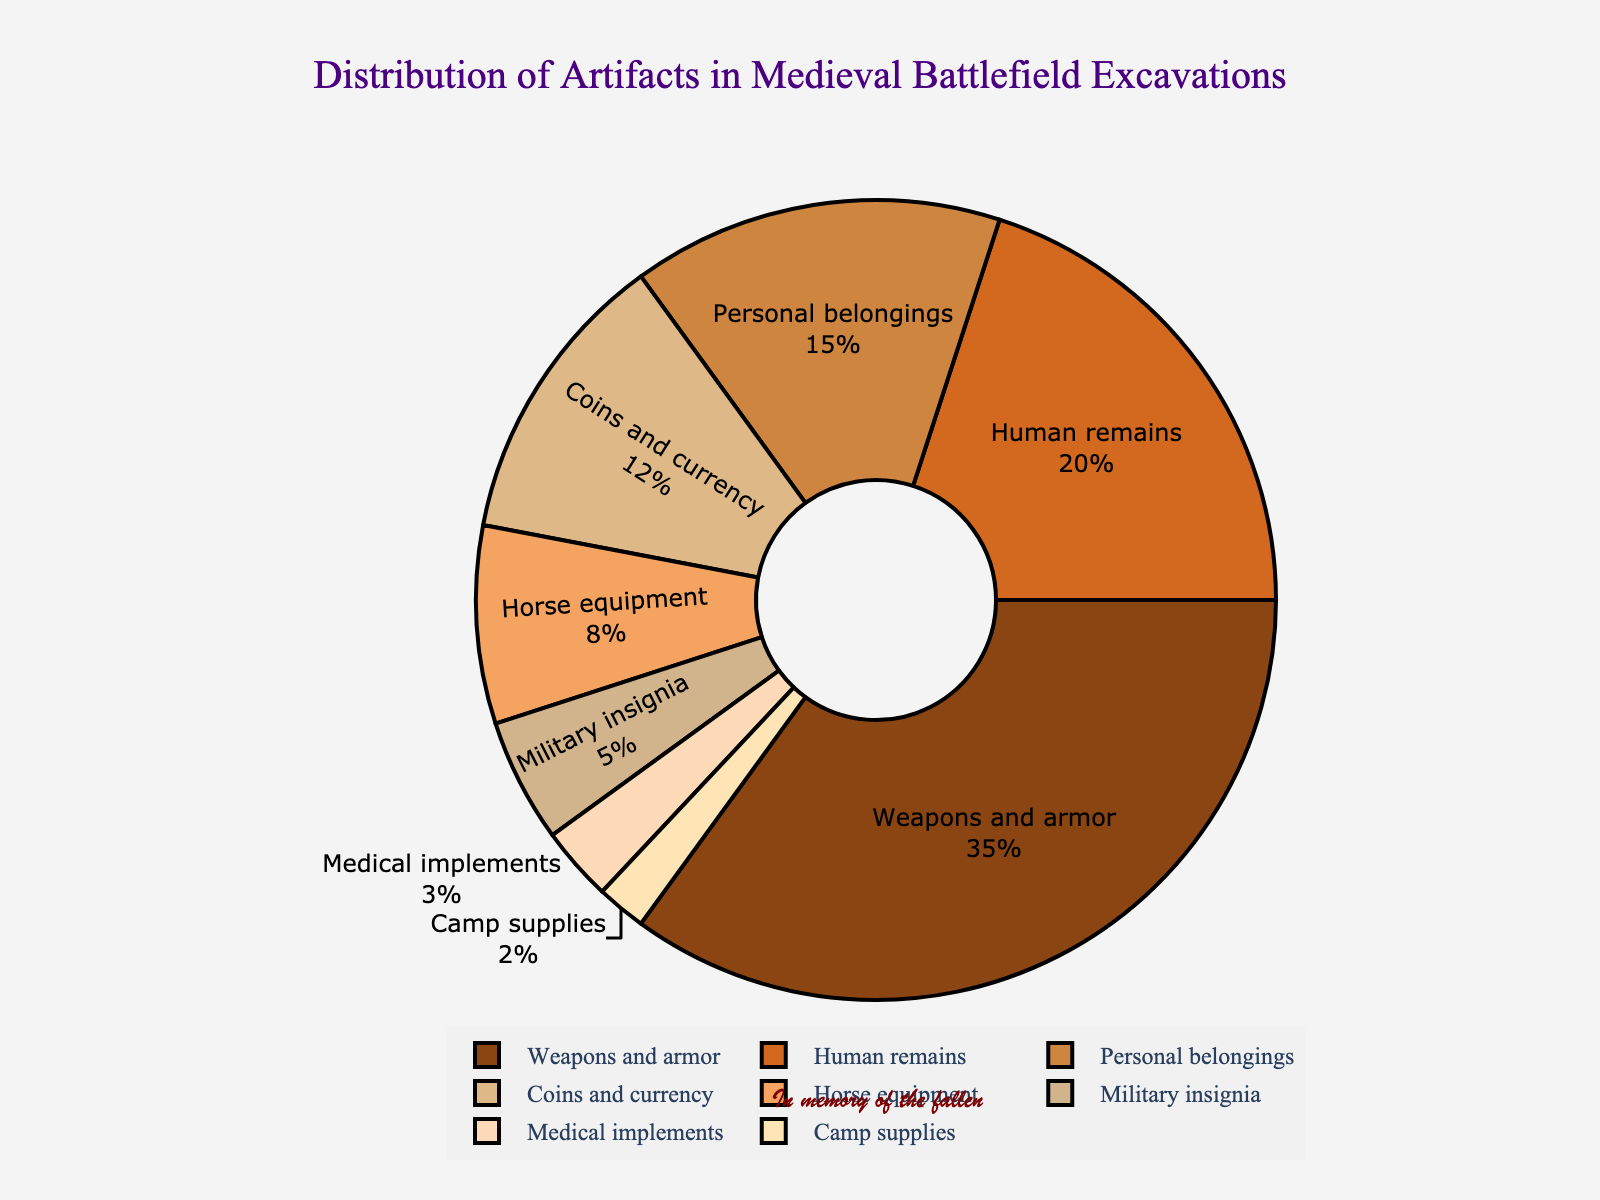What's the category with the largest percentage? The category with the largest percentage is the one with the highest value in the pie chart. In this case, it's "Weapons and armor" with 35%.
Answer: Weapons and armor Which category has a greater percentage: Human remains or Personal belongings? To determine this, we compare the percentages of the two categories. Human remains have 20%, while Personal belongings have 15%. Therefore, Human remains have a greater percentage.
Answer: Human remains What is the combined percentage of Coins and currency, Horse equipment, and Military insignia? To find the combined percentage, we need to sum the percentages of the three categories: Coins and currency (12%) + Horse equipment (8%) + Military insignia (5%) = 25%.
Answer: 25% Is the percentage of Medical implements greater than or equal to Camp supplies? We compare the values of both categories. Medical implements have 3%, and Camp supplies have 2%. Since 3% is greater than 2%, the percentage of Medical implements is greater than Camp supplies.
Answer: Yes What is the difference in percentage between Weapons and armor and Human remains? To find the difference, subtract the percentage of Human remains from the percentage of Weapons and armor: 35% - 20% = 15%.
Answer: 15% Which segment is represented by the brown color? The brown color refers to one of the shades used in the pie chart. The segment for "Weapons and armor" is in brown color.
Answer: Weapons and armor How many categories have a percentage greater than 10%? We look at each category's percentage to see which ones are greater than 10%. Weapons and armor (35%), Human remains (20%), Personal belongings (15%), and Coins and currency (12%) are all greater than 10%. So, there are 4 categories.
Answer: 4 What is the average percentage of categories Military insignia, Medical implements, and Camp supplies? To find the average, sum the percentages of the three categories and divide by the number of categories: (5% + 3% + 2%) / 3 = 10% / 3 ≈ 3.33%.
Answer: 3.33% Is the percentage of Personal belongings more than the combined percentage of Military insignia and Camp supplies? Calculate the combined percentage of Military insignia and Camp supplies: 5% + 2% = 7%. Compare it with Personal belongings which have 15%. Since 15% is more than 7%, Personal belongings have a higher percentage.
Answer: Yes 